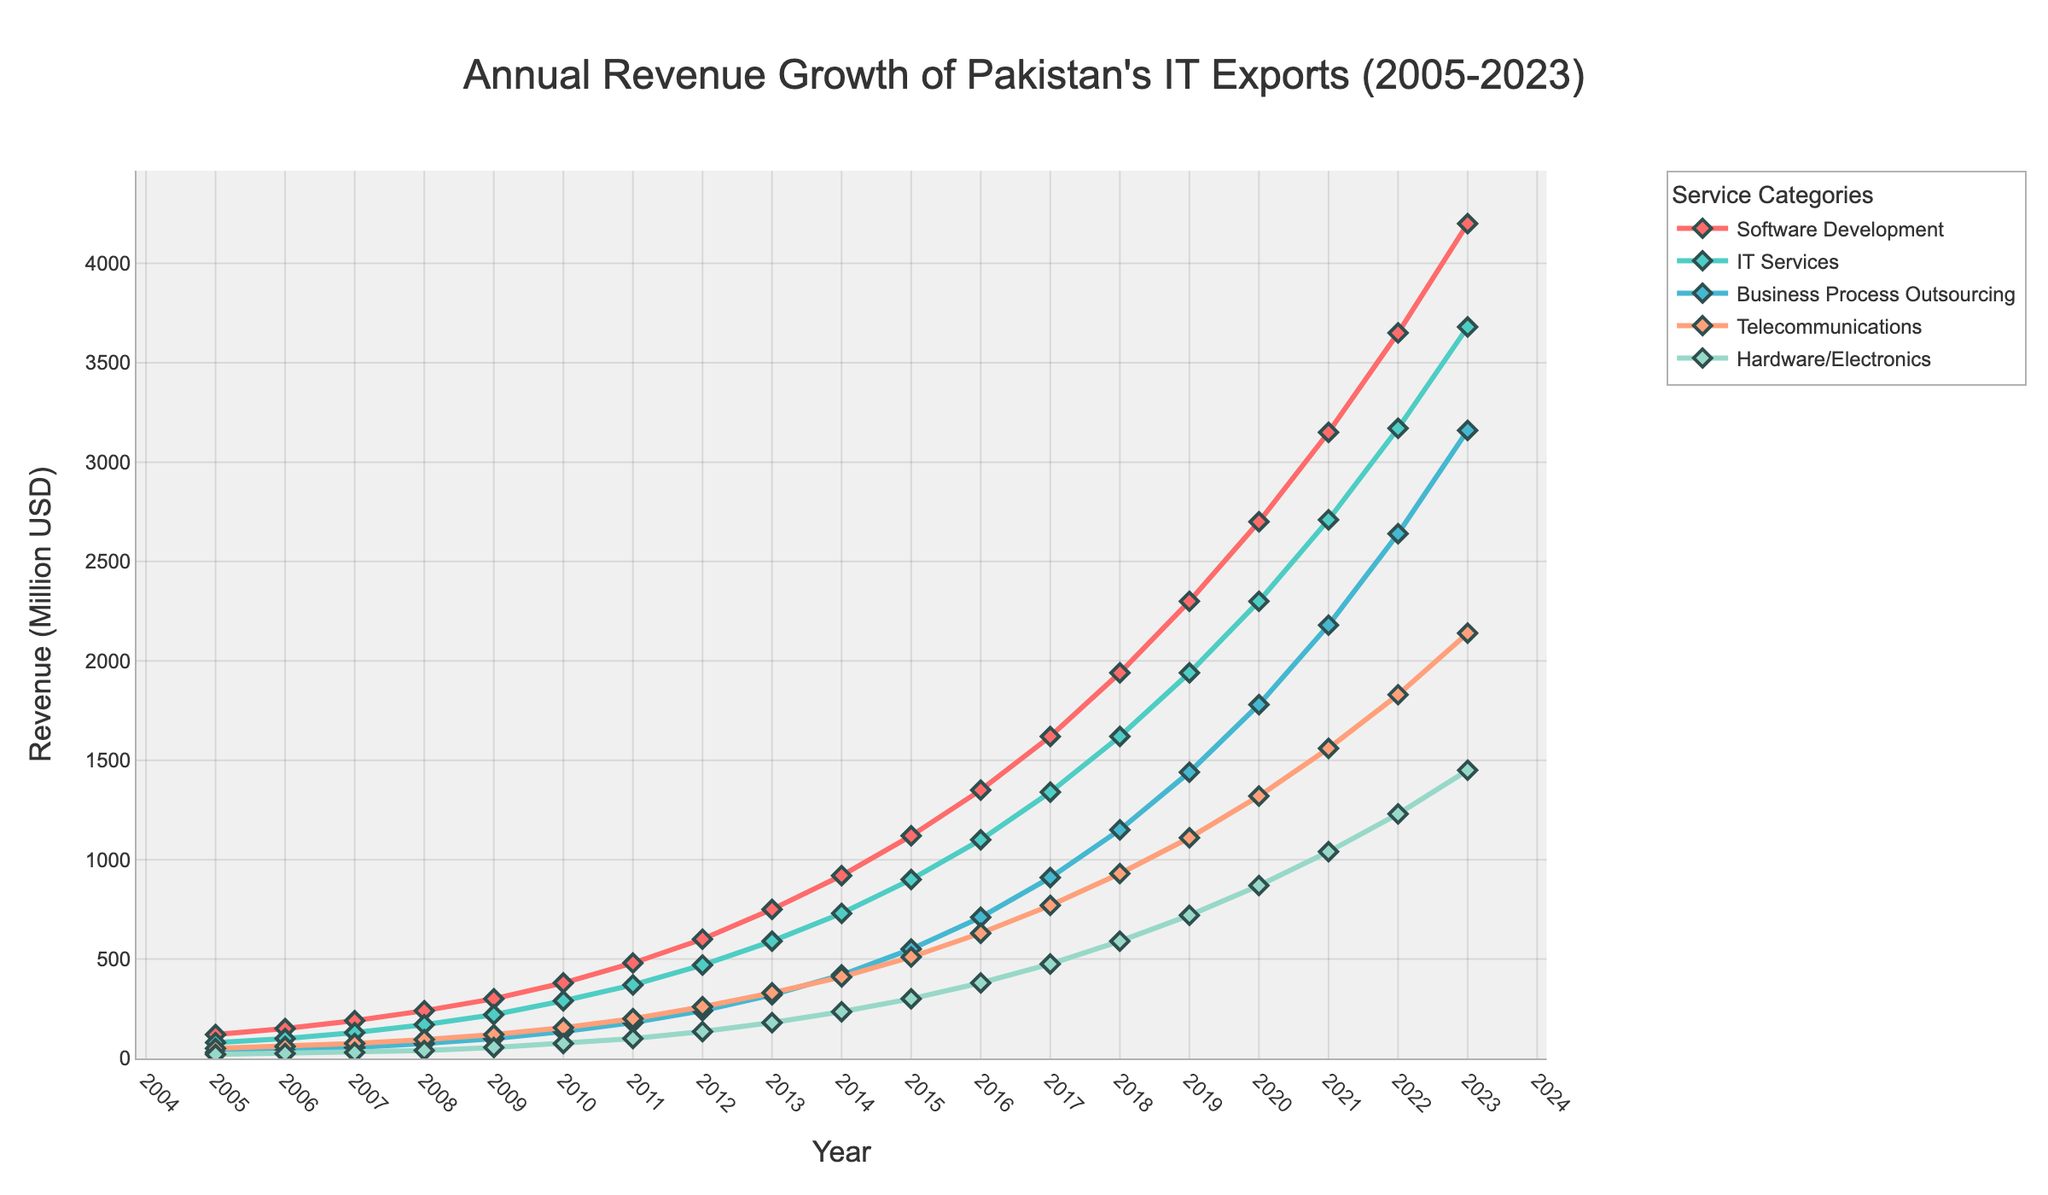Which service category had the highest revenue in 2023? By observing the endpoints of each line at the year 2023, we find that the Software Development line is at the highest vertical position, indicating it had the highest revenue
Answer: Software Development Which two service categories had the closest revenue figures in 2010? Looking at the data points for 2010, we see that IT Services and Telecommunications have very close values, around 290 and 155 respectively
Answer: IT Services and Telecommunications Over how many years did the revenue for Business Process Outsourcing increase by more than 1000 million USD? The revenue in 2005 was 30, and it reached 3160 by 2023. Subtracting 30 from 3160 gives an increase of 3130. Dividing this by 1000 gives approximately 3.13, so the revenue increased by more than 1000 million USD over approximately 3.13 periods. Since time is continuous, we count complete years, or otherwise can closely see from 2012-2023 that it’s more than 3 years.
Answer: 11 years What is the difference in revenue between Software Development and Hardware/Electronics in 2023? The revenue for Software Development in 2023 is 4200, and for Hardware/Electronics, it is 1450. The difference is 4200 - 1450 = 2750
Answer: 2750 By how much did the revenue for IT Services grow from 2009 to 2015? The revenue for IT Services in 2009 was 220, and it reached 900 in 2015. The growth is 900 - 220 = 680
Answer: 680 Which category experienced the highest growth rate between 2005 and 2023? By visually comparing the overall slopes of each line, we observe that Software Development exhibits the steepest and most consistent upward trajectory
Answer: Software Development Compare the revenues of all categories in 2015. Which category was third highest that year? Observing the heights of the points for 2015, we see Software Development (1120), IT Services (900), Business Process Outsourcing (550), Telecommunications (510), and Hardware/Electronics (300). Business Process Outsourcing is the third highest
Answer: Business Process Outsourcing In which year did Telecommunications first surpass 1000 million USD? Observing the graph, Telecommunications first crosses the 1000 mark sometime between 2018 and 2019. Specifically, it reached this milestone in 2019
Answer: 2019 What is the average revenue for IT Services between 2010 and 2015? Adding the revenues for IT Services for the years 2010 to 2015 (290 + 370 + 470 + 590 + 730 + 900) gives 3350. Dividing by 6, the average is 3350/6 ≈ 558.33
Answer: 558.33 